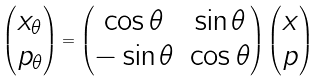Convert formula to latex. <formula><loc_0><loc_0><loc_500><loc_500>\begin{pmatrix} x _ { \theta } \\ p _ { \theta } \end{pmatrix} = \begin{pmatrix} \cos \theta & \sin \theta \\ - \sin \theta & \cos \theta \end{pmatrix} \begin{pmatrix} x \\ p \end{pmatrix}</formula> 